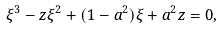Convert formula to latex. <formula><loc_0><loc_0><loc_500><loc_500>\xi ^ { 3 } - z \xi ^ { 2 } + ( 1 - a ^ { 2 } ) \xi + a ^ { 2 } z = 0 ,</formula> 